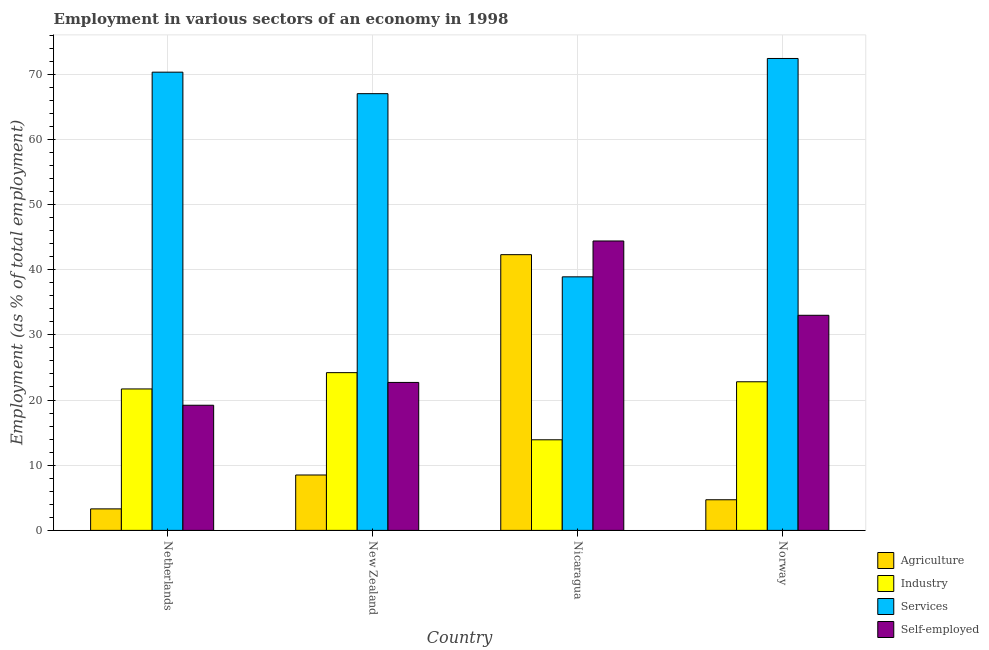How many groups of bars are there?
Your answer should be very brief. 4. Are the number of bars per tick equal to the number of legend labels?
Provide a succinct answer. Yes. How many bars are there on the 2nd tick from the left?
Your response must be concise. 4. What is the percentage of workers in industry in Norway?
Provide a succinct answer. 22.8. Across all countries, what is the maximum percentage of workers in agriculture?
Ensure brevity in your answer.  42.3. Across all countries, what is the minimum percentage of workers in services?
Your answer should be very brief. 38.9. In which country was the percentage of self employed workers maximum?
Provide a short and direct response. Nicaragua. In which country was the percentage of workers in services minimum?
Offer a terse response. Nicaragua. What is the total percentage of workers in industry in the graph?
Offer a terse response. 82.6. What is the difference between the percentage of workers in industry in Nicaragua and that in Norway?
Offer a terse response. -8.9. What is the difference between the percentage of workers in services in New Zealand and the percentage of workers in industry in Netherlands?
Offer a terse response. 45.3. What is the average percentage of workers in industry per country?
Ensure brevity in your answer.  20.65. What is the difference between the percentage of workers in industry and percentage of workers in agriculture in Netherlands?
Your answer should be compact. 18.4. In how many countries, is the percentage of workers in agriculture greater than 18 %?
Offer a terse response. 1. What is the ratio of the percentage of workers in agriculture in Netherlands to that in Norway?
Your answer should be very brief. 0.7. What is the difference between the highest and the second highest percentage of workers in industry?
Offer a terse response. 1.4. What is the difference between the highest and the lowest percentage of workers in agriculture?
Your answer should be compact. 39. In how many countries, is the percentage of workers in industry greater than the average percentage of workers in industry taken over all countries?
Your answer should be compact. 3. Is the sum of the percentage of workers in services in Netherlands and New Zealand greater than the maximum percentage of self employed workers across all countries?
Give a very brief answer. Yes. Is it the case that in every country, the sum of the percentage of workers in services and percentage of workers in agriculture is greater than the sum of percentage of workers in industry and percentage of self employed workers?
Offer a very short reply. Yes. What does the 4th bar from the left in New Zealand represents?
Your answer should be compact. Self-employed. What does the 2nd bar from the right in Netherlands represents?
Your response must be concise. Services. How many bars are there?
Give a very brief answer. 16. Are all the bars in the graph horizontal?
Give a very brief answer. No. Does the graph contain grids?
Provide a short and direct response. Yes. What is the title of the graph?
Your answer should be very brief. Employment in various sectors of an economy in 1998. Does "Public sector management" appear as one of the legend labels in the graph?
Provide a succinct answer. No. What is the label or title of the X-axis?
Give a very brief answer. Country. What is the label or title of the Y-axis?
Make the answer very short. Employment (as % of total employment). What is the Employment (as % of total employment) of Agriculture in Netherlands?
Give a very brief answer. 3.3. What is the Employment (as % of total employment) in Industry in Netherlands?
Provide a succinct answer. 21.7. What is the Employment (as % of total employment) in Services in Netherlands?
Provide a succinct answer. 70.3. What is the Employment (as % of total employment) of Self-employed in Netherlands?
Make the answer very short. 19.2. What is the Employment (as % of total employment) in Agriculture in New Zealand?
Provide a short and direct response. 8.5. What is the Employment (as % of total employment) of Industry in New Zealand?
Give a very brief answer. 24.2. What is the Employment (as % of total employment) in Services in New Zealand?
Give a very brief answer. 67. What is the Employment (as % of total employment) of Self-employed in New Zealand?
Your response must be concise. 22.7. What is the Employment (as % of total employment) of Agriculture in Nicaragua?
Give a very brief answer. 42.3. What is the Employment (as % of total employment) in Industry in Nicaragua?
Offer a very short reply. 13.9. What is the Employment (as % of total employment) of Services in Nicaragua?
Offer a very short reply. 38.9. What is the Employment (as % of total employment) in Self-employed in Nicaragua?
Provide a short and direct response. 44.4. What is the Employment (as % of total employment) of Agriculture in Norway?
Keep it short and to the point. 4.7. What is the Employment (as % of total employment) of Industry in Norway?
Offer a very short reply. 22.8. What is the Employment (as % of total employment) in Services in Norway?
Provide a short and direct response. 72.4. Across all countries, what is the maximum Employment (as % of total employment) in Agriculture?
Make the answer very short. 42.3. Across all countries, what is the maximum Employment (as % of total employment) of Industry?
Make the answer very short. 24.2. Across all countries, what is the maximum Employment (as % of total employment) of Services?
Offer a terse response. 72.4. Across all countries, what is the maximum Employment (as % of total employment) of Self-employed?
Your answer should be very brief. 44.4. Across all countries, what is the minimum Employment (as % of total employment) in Agriculture?
Your answer should be compact. 3.3. Across all countries, what is the minimum Employment (as % of total employment) of Industry?
Provide a short and direct response. 13.9. Across all countries, what is the minimum Employment (as % of total employment) of Services?
Your response must be concise. 38.9. Across all countries, what is the minimum Employment (as % of total employment) of Self-employed?
Make the answer very short. 19.2. What is the total Employment (as % of total employment) in Agriculture in the graph?
Your answer should be compact. 58.8. What is the total Employment (as % of total employment) in Industry in the graph?
Offer a terse response. 82.6. What is the total Employment (as % of total employment) in Services in the graph?
Make the answer very short. 248.6. What is the total Employment (as % of total employment) of Self-employed in the graph?
Give a very brief answer. 119.3. What is the difference between the Employment (as % of total employment) of Agriculture in Netherlands and that in New Zealand?
Your answer should be compact. -5.2. What is the difference between the Employment (as % of total employment) of Services in Netherlands and that in New Zealand?
Make the answer very short. 3.3. What is the difference between the Employment (as % of total employment) in Self-employed in Netherlands and that in New Zealand?
Keep it short and to the point. -3.5. What is the difference between the Employment (as % of total employment) of Agriculture in Netherlands and that in Nicaragua?
Your answer should be very brief. -39. What is the difference between the Employment (as % of total employment) of Industry in Netherlands and that in Nicaragua?
Give a very brief answer. 7.8. What is the difference between the Employment (as % of total employment) in Services in Netherlands and that in Nicaragua?
Your response must be concise. 31.4. What is the difference between the Employment (as % of total employment) of Self-employed in Netherlands and that in Nicaragua?
Your response must be concise. -25.2. What is the difference between the Employment (as % of total employment) in Services in Netherlands and that in Norway?
Provide a succinct answer. -2.1. What is the difference between the Employment (as % of total employment) in Self-employed in Netherlands and that in Norway?
Your answer should be compact. -13.8. What is the difference between the Employment (as % of total employment) in Agriculture in New Zealand and that in Nicaragua?
Ensure brevity in your answer.  -33.8. What is the difference between the Employment (as % of total employment) of Industry in New Zealand and that in Nicaragua?
Offer a terse response. 10.3. What is the difference between the Employment (as % of total employment) of Services in New Zealand and that in Nicaragua?
Give a very brief answer. 28.1. What is the difference between the Employment (as % of total employment) in Self-employed in New Zealand and that in Nicaragua?
Provide a succinct answer. -21.7. What is the difference between the Employment (as % of total employment) of Services in New Zealand and that in Norway?
Provide a short and direct response. -5.4. What is the difference between the Employment (as % of total employment) of Self-employed in New Zealand and that in Norway?
Offer a terse response. -10.3. What is the difference between the Employment (as % of total employment) in Agriculture in Nicaragua and that in Norway?
Offer a very short reply. 37.6. What is the difference between the Employment (as % of total employment) in Industry in Nicaragua and that in Norway?
Make the answer very short. -8.9. What is the difference between the Employment (as % of total employment) in Services in Nicaragua and that in Norway?
Make the answer very short. -33.5. What is the difference between the Employment (as % of total employment) of Self-employed in Nicaragua and that in Norway?
Provide a succinct answer. 11.4. What is the difference between the Employment (as % of total employment) of Agriculture in Netherlands and the Employment (as % of total employment) of Industry in New Zealand?
Ensure brevity in your answer.  -20.9. What is the difference between the Employment (as % of total employment) of Agriculture in Netherlands and the Employment (as % of total employment) of Services in New Zealand?
Give a very brief answer. -63.7. What is the difference between the Employment (as % of total employment) in Agriculture in Netherlands and the Employment (as % of total employment) in Self-employed in New Zealand?
Offer a very short reply. -19.4. What is the difference between the Employment (as % of total employment) in Industry in Netherlands and the Employment (as % of total employment) in Services in New Zealand?
Your answer should be very brief. -45.3. What is the difference between the Employment (as % of total employment) of Services in Netherlands and the Employment (as % of total employment) of Self-employed in New Zealand?
Keep it short and to the point. 47.6. What is the difference between the Employment (as % of total employment) of Agriculture in Netherlands and the Employment (as % of total employment) of Services in Nicaragua?
Offer a terse response. -35.6. What is the difference between the Employment (as % of total employment) of Agriculture in Netherlands and the Employment (as % of total employment) of Self-employed in Nicaragua?
Your answer should be very brief. -41.1. What is the difference between the Employment (as % of total employment) of Industry in Netherlands and the Employment (as % of total employment) of Services in Nicaragua?
Ensure brevity in your answer.  -17.2. What is the difference between the Employment (as % of total employment) of Industry in Netherlands and the Employment (as % of total employment) of Self-employed in Nicaragua?
Offer a terse response. -22.7. What is the difference between the Employment (as % of total employment) of Services in Netherlands and the Employment (as % of total employment) of Self-employed in Nicaragua?
Keep it short and to the point. 25.9. What is the difference between the Employment (as % of total employment) in Agriculture in Netherlands and the Employment (as % of total employment) in Industry in Norway?
Offer a terse response. -19.5. What is the difference between the Employment (as % of total employment) in Agriculture in Netherlands and the Employment (as % of total employment) in Services in Norway?
Your answer should be very brief. -69.1. What is the difference between the Employment (as % of total employment) in Agriculture in Netherlands and the Employment (as % of total employment) in Self-employed in Norway?
Keep it short and to the point. -29.7. What is the difference between the Employment (as % of total employment) in Industry in Netherlands and the Employment (as % of total employment) in Services in Norway?
Your answer should be compact. -50.7. What is the difference between the Employment (as % of total employment) of Industry in Netherlands and the Employment (as % of total employment) of Self-employed in Norway?
Make the answer very short. -11.3. What is the difference between the Employment (as % of total employment) of Services in Netherlands and the Employment (as % of total employment) of Self-employed in Norway?
Your answer should be compact. 37.3. What is the difference between the Employment (as % of total employment) of Agriculture in New Zealand and the Employment (as % of total employment) of Services in Nicaragua?
Make the answer very short. -30.4. What is the difference between the Employment (as % of total employment) of Agriculture in New Zealand and the Employment (as % of total employment) of Self-employed in Nicaragua?
Keep it short and to the point. -35.9. What is the difference between the Employment (as % of total employment) in Industry in New Zealand and the Employment (as % of total employment) in Services in Nicaragua?
Ensure brevity in your answer.  -14.7. What is the difference between the Employment (as % of total employment) of Industry in New Zealand and the Employment (as % of total employment) of Self-employed in Nicaragua?
Ensure brevity in your answer.  -20.2. What is the difference between the Employment (as % of total employment) in Services in New Zealand and the Employment (as % of total employment) in Self-employed in Nicaragua?
Provide a short and direct response. 22.6. What is the difference between the Employment (as % of total employment) of Agriculture in New Zealand and the Employment (as % of total employment) of Industry in Norway?
Your response must be concise. -14.3. What is the difference between the Employment (as % of total employment) of Agriculture in New Zealand and the Employment (as % of total employment) of Services in Norway?
Provide a succinct answer. -63.9. What is the difference between the Employment (as % of total employment) of Agriculture in New Zealand and the Employment (as % of total employment) of Self-employed in Norway?
Provide a short and direct response. -24.5. What is the difference between the Employment (as % of total employment) in Industry in New Zealand and the Employment (as % of total employment) in Services in Norway?
Your response must be concise. -48.2. What is the difference between the Employment (as % of total employment) in Industry in New Zealand and the Employment (as % of total employment) in Self-employed in Norway?
Give a very brief answer. -8.8. What is the difference between the Employment (as % of total employment) of Agriculture in Nicaragua and the Employment (as % of total employment) of Industry in Norway?
Offer a terse response. 19.5. What is the difference between the Employment (as % of total employment) of Agriculture in Nicaragua and the Employment (as % of total employment) of Services in Norway?
Offer a terse response. -30.1. What is the difference between the Employment (as % of total employment) in Industry in Nicaragua and the Employment (as % of total employment) in Services in Norway?
Ensure brevity in your answer.  -58.5. What is the difference between the Employment (as % of total employment) of Industry in Nicaragua and the Employment (as % of total employment) of Self-employed in Norway?
Your answer should be compact. -19.1. What is the average Employment (as % of total employment) of Industry per country?
Your answer should be very brief. 20.65. What is the average Employment (as % of total employment) of Services per country?
Offer a very short reply. 62.15. What is the average Employment (as % of total employment) of Self-employed per country?
Provide a short and direct response. 29.82. What is the difference between the Employment (as % of total employment) of Agriculture and Employment (as % of total employment) of Industry in Netherlands?
Your answer should be compact. -18.4. What is the difference between the Employment (as % of total employment) of Agriculture and Employment (as % of total employment) of Services in Netherlands?
Provide a succinct answer. -67. What is the difference between the Employment (as % of total employment) in Agriculture and Employment (as % of total employment) in Self-employed in Netherlands?
Offer a very short reply. -15.9. What is the difference between the Employment (as % of total employment) of Industry and Employment (as % of total employment) of Services in Netherlands?
Keep it short and to the point. -48.6. What is the difference between the Employment (as % of total employment) of Industry and Employment (as % of total employment) of Self-employed in Netherlands?
Provide a succinct answer. 2.5. What is the difference between the Employment (as % of total employment) in Services and Employment (as % of total employment) in Self-employed in Netherlands?
Give a very brief answer. 51.1. What is the difference between the Employment (as % of total employment) in Agriculture and Employment (as % of total employment) in Industry in New Zealand?
Your answer should be compact. -15.7. What is the difference between the Employment (as % of total employment) in Agriculture and Employment (as % of total employment) in Services in New Zealand?
Provide a succinct answer. -58.5. What is the difference between the Employment (as % of total employment) of Industry and Employment (as % of total employment) of Services in New Zealand?
Provide a succinct answer. -42.8. What is the difference between the Employment (as % of total employment) of Services and Employment (as % of total employment) of Self-employed in New Zealand?
Make the answer very short. 44.3. What is the difference between the Employment (as % of total employment) of Agriculture and Employment (as % of total employment) of Industry in Nicaragua?
Your response must be concise. 28.4. What is the difference between the Employment (as % of total employment) of Industry and Employment (as % of total employment) of Self-employed in Nicaragua?
Make the answer very short. -30.5. What is the difference between the Employment (as % of total employment) of Services and Employment (as % of total employment) of Self-employed in Nicaragua?
Your answer should be very brief. -5.5. What is the difference between the Employment (as % of total employment) in Agriculture and Employment (as % of total employment) in Industry in Norway?
Offer a terse response. -18.1. What is the difference between the Employment (as % of total employment) of Agriculture and Employment (as % of total employment) of Services in Norway?
Ensure brevity in your answer.  -67.7. What is the difference between the Employment (as % of total employment) of Agriculture and Employment (as % of total employment) of Self-employed in Norway?
Your response must be concise. -28.3. What is the difference between the Employment (as % of total employment) of Industry and Employment (as % of total employment) of Services in Norway?
Your response must be concise. -49.6. What is the difference between the Employment (as % of total employment) in Industry and Employment (as % of total employment) in Self-employed in Norway?
Ensure brevity in your answer.  -10.2. What is the difference between the Employment (as % of total employment) of Services and Employment (as % of total employment) of Self-employed in Norway?
Provide a short and direct response. 39.4. What is the ratio of the Employment (as % of total employment) in Agriculture in Netherlands to that in New Zealand?
Your response must be concise. 0.39. What is the ratio of the Employment (as % of total employment) of Industry in Netherlands to that in New Zealand?
Make the answer very short. 0.9. What is the ratio of the Employment (as % of total employment) in Services in Netherlands to that in New Zealand?
Make the answer very short. 1.05. What is the ratio of the Employment (as % of total employment) of Self-employed in Netherlands to that in New Zealand?
Keep it short and to the point. 0.85. What is the ratio of the Employment (as % of total employment) in Agriculture in Netherlands to that in Nicaragua?
Your response must be concise. 0.08. What is the ratio of the Employment (as % of total employment) in Industry in Netherlands to that in Nicaragua?
Your response must be concise. 1.56. What is the ratio of the Employment (as % of total employment) of Services in Netherlands to that in Nicaragua?
Make the answer very short. 1.81. What is the ratio of the Employment (as % of total employment) in Self-employed in Netherlands to that in Nicaragua?
Your answer should be compact. 0.43. What is the ratio of the Employment (as % of total employment) in Agriculture in Netherlands to that in Norway?
Provide a short and direct response. 0.7. What is the ratio of the Employment (as % of total employment) in Industry in Netherlands to that in Norway?
Offer a terse response. 0.95. What is the ratio of the Employment (as % of total employment) in Services in Netherlands to that in Norway?
Offer a terse response. 0.97. What is the ratio of the Employment (as % of total employment) in Self-employed in Netherlands to that in Norway?
Give a very brief answer. 0.58. What is the ratio of the Employment (as % of total employment) of Agriculture in New Zealand to that in Nicaragua?
Keep it short and to the point. 0.2. What is the ratio of the Employment (as % of total employment) of Industry in New Zealand to that in Nicaragua?
Your answer should be compact. 1.74. What is the ratio of the Employment (as % of total employment) in Services in New Zealand to that in Nicaragua?
Offer a terse response. 1.72. What is the ratio of the Employment (as % of total employment) in Self-employed in New Zealand to that in Nicaragua?
Ensure brevity in your answer.  0.51. What is the ratio of the Employment (as % of total employment) of Agriculture in New Zealand to that in Norway?
Make the answer very short. 1.81. What is the ratio of the Employment (as % of total employment) in Industry in New Zealand to that in Norway?
Offer a terse response. 1.06. What is the ratio of the Employment (as % of total employment) in Services in New Zealand to that in Norway?
Your answer should be compact. 0.93. What is the ratio of the Employment (as % of total employment) of Self-employed in New Zealand to that in Norway?
Offer a very short reply. 0.69. What is the ratio of the Employment (as % of total employment) in Industry in Nicaragua to that in Norway?
Your response must be concise. 0.61. What is the ratio of the Employment (as % of total employment) in Services in Nicaragua to that in Norway?
Ensure brevity in your answer.  0.54. What is the ratio of the Employment (as % of total employment) in Self-employed in Nicaragua to that in Norway?
Keep it short and to the point. 1.35. What is the difference between the highest and the second highest Employment (as % of total employment) of Agriculture?
Make the answer very short. 33.8. What is the difference between the highest and the second highest Employment (as % of total employment) of Services?
Provide a short and direct response. 2.1. What is the difference between the highest and the second highest Employment (as % of total employment) in Self-employed?
Your answer should be compact. 11.4. What is the difference between the highest and the lowest Employment (as % of total employment) of Services?
Keep it short and to the point. 33.5. What is the difference between the highest and the lowest Employment (as % of total employment) in Self-employed?
Your response must be concise. 25.2. 